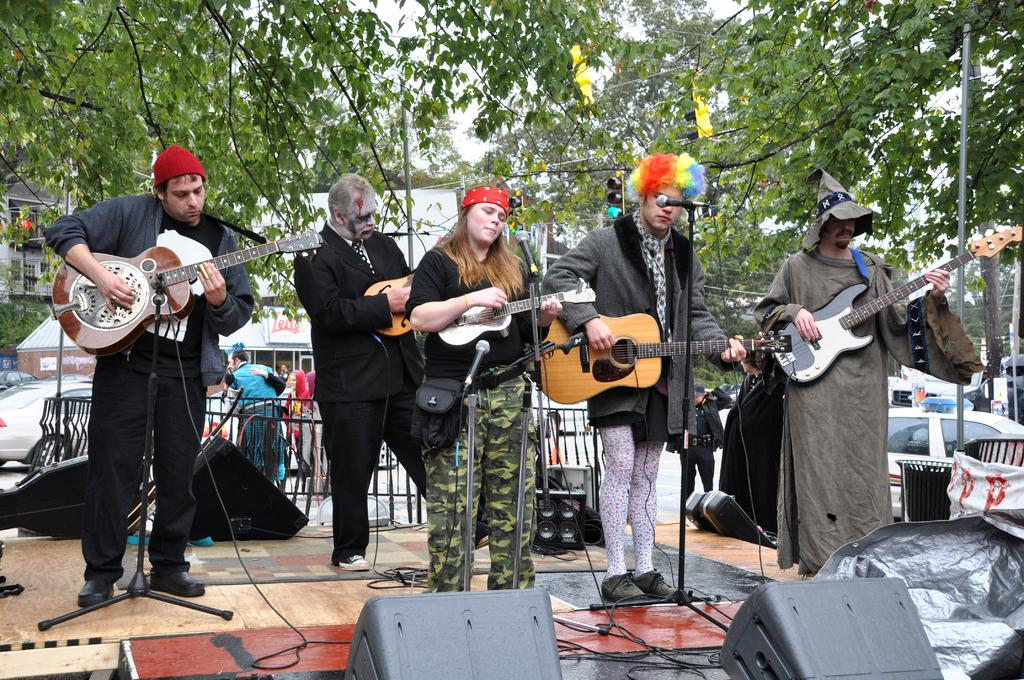What are the people in the image doing? The people in the image are playing guitars. What equipment is set up for the people playing guitars? There is a microphone in front of the people and speakers are present in the image. What can be seen in the background of the image? Trees and cars are visible in the background. Where is the cave located in the image? There is no cave present in the image. What type of bucket can be seen being used by the people playing guitars? There is no bucket visible in the image; the people are playing guitars and using a microphone and speakers for their performance. 